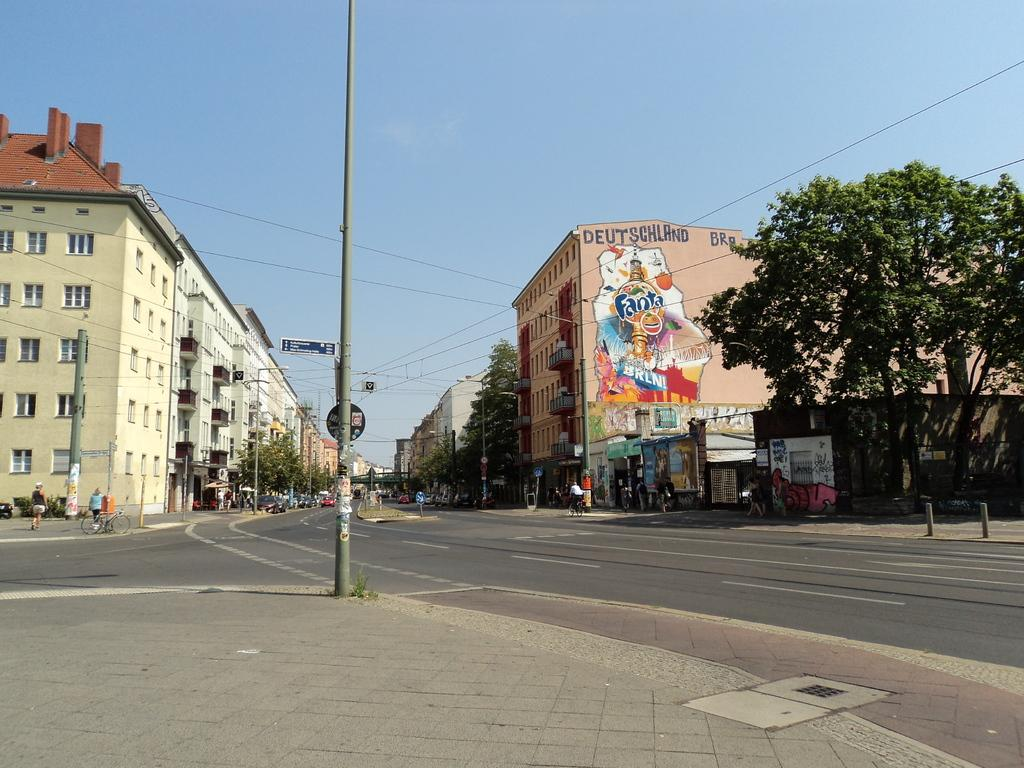What type of structures can be seen in the image? There are buildings in the image. What other natural elements are present in the image? There are trees in the image. What else can be seen in the image that is related to infrastructure? There are poles with wires in the image. What part of the natural environment is visible in the image? The sky is visible at the top of the image. What is the man-made feature at the bottom of the image? There is a road at the bottom of the image. Are there any living beings visible in the image? Yes, there are people visible in the image. What type of spot can be seen on the people's faces in the image? There is no mention of spots on people's faces in the image; the provided facts do not include any information about spots or facial features. 